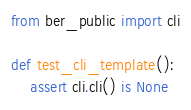<code> <loc_0><loc_0><loc_500><loc_500><_Python_>from ber_public import cli

def test_cli_template():
    assert cli.cli() is None
</code> 